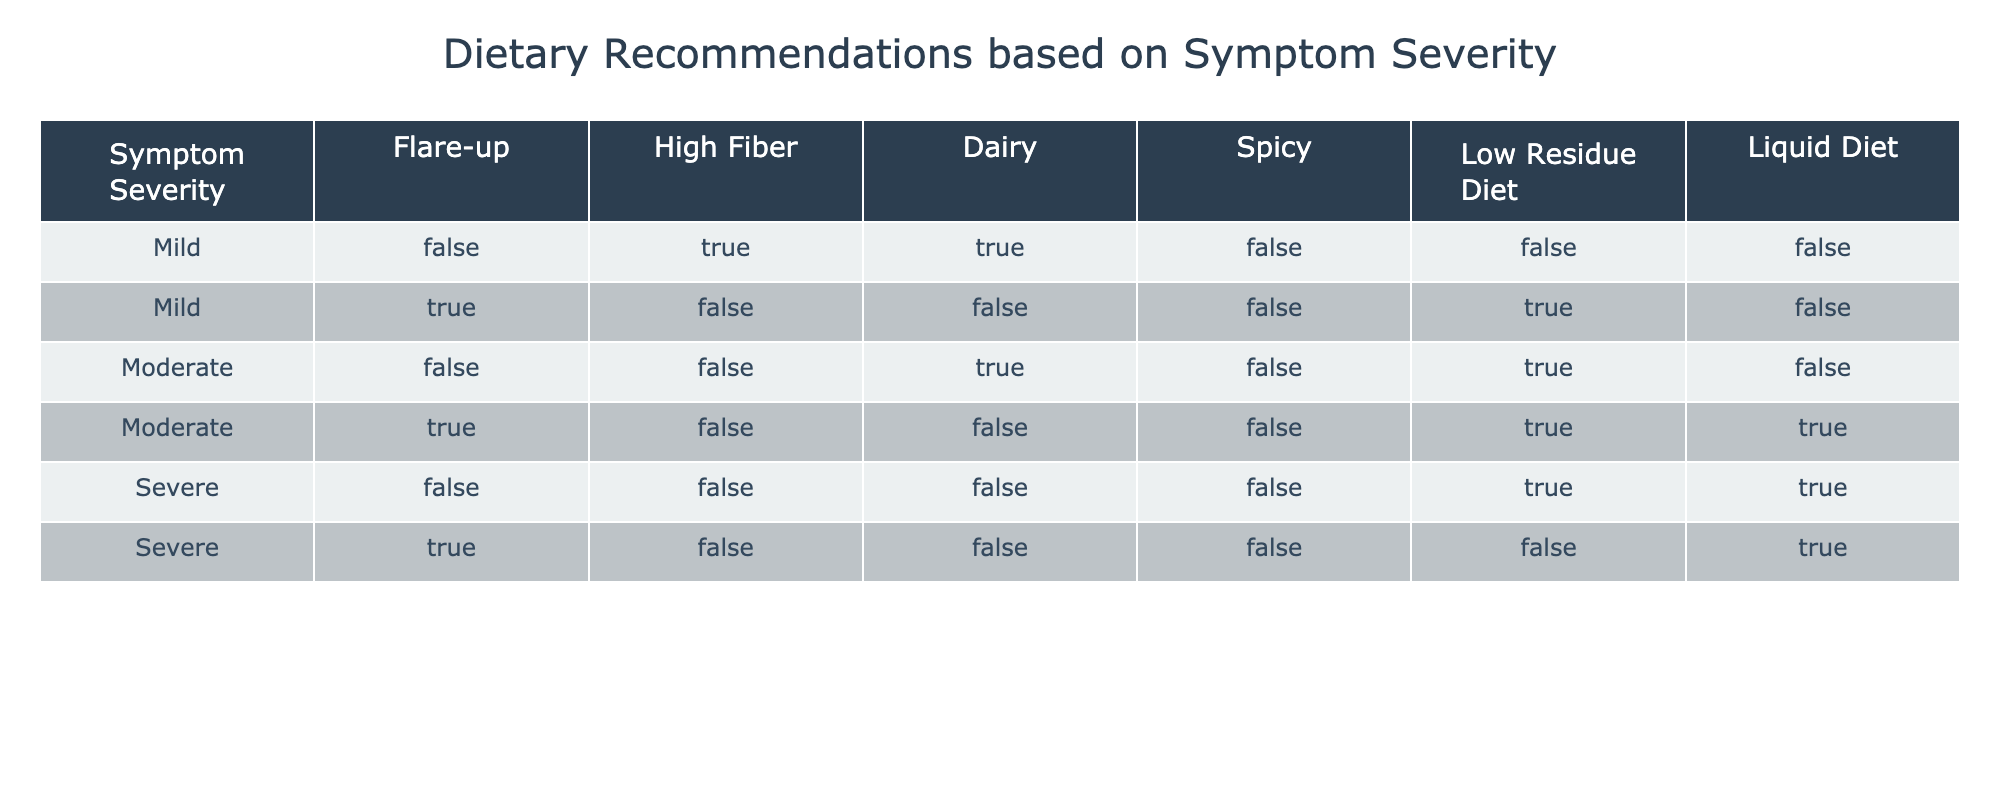What dietary recommendation is made for a mild flare-up? In the row corresponding to "Mild" with "Flare-up" as true, the recommended diets are "Low Residue Diet" (True) and "Liquid Diet" (False). Thus, the only recommendation is to follow a Low Residue Diet.
Answer: Low Residue Diet Is high fiber recommended during a severe flare-up? In the "Severe" section, both entries indicate "High Fiber" to be false. Therefore, high fiber is not recommended during a severe flare-up.
Answer: No How many symptom severities recommend a liquid diet? By examining the table, the "Liquid Diet" is true for "Moderate" during a flare-up and for "Severe" when there's no flare-up, giving us a total of 3 instances when a liquid diet is recommended from different rows.
Answer: 3 For moderate symptoms, which diet options are recommended during a flare-up? Looking at the "Moderate" row with "Flare-up" marked as true, the recommendations are "High Fiber" (False), "Dairy" (False), "Spicy" (False), "Low Residue Diet" (True), and "Liquid Diet" (True), resulting in the recommendation of a Low Residue Diet and a Liquid Diet.
Answer: Low Residue Diet, Liquid Diet Is dairy recommended for patients with mild symptoms? In the "Mild" row, dairy is indicated as true. Hence, dairy is recommended for patients experiencing mild symptoms.
Answer: Yes What is the total number of recommendations for each severity level? The recommendations per severity are as follows: Mild has 2 recommendations (High Fiber and Dairy), Moderate has 3 (Dairy, Low Residue Diet, and Liquid Diet), and Severe has 2 (Low Residue Diet and Liquid Diet). Thus, the total counts are Mild: 2, Moderate: 3, Severe: 2.
Answer: Mild: 2, Moderate: 3, Severe: 2 What is recommended during a moderate symptom flare-up? Referencing the Moderate row with Flare-up marked true, we see Low Residue Diet and a Liquid Diet are the recommended options based on their trueness according to the table.
Answer: Low Residue Diet, Liquid Diet Is a low residue diet ever recommended during a mild flare-up? In the table, for "Mild" with "Flare-up" marked true, the entry indicates that "Low Residue Diet" is true, confirming that it is indeed recommended during this scenario.
Answer: Yes 